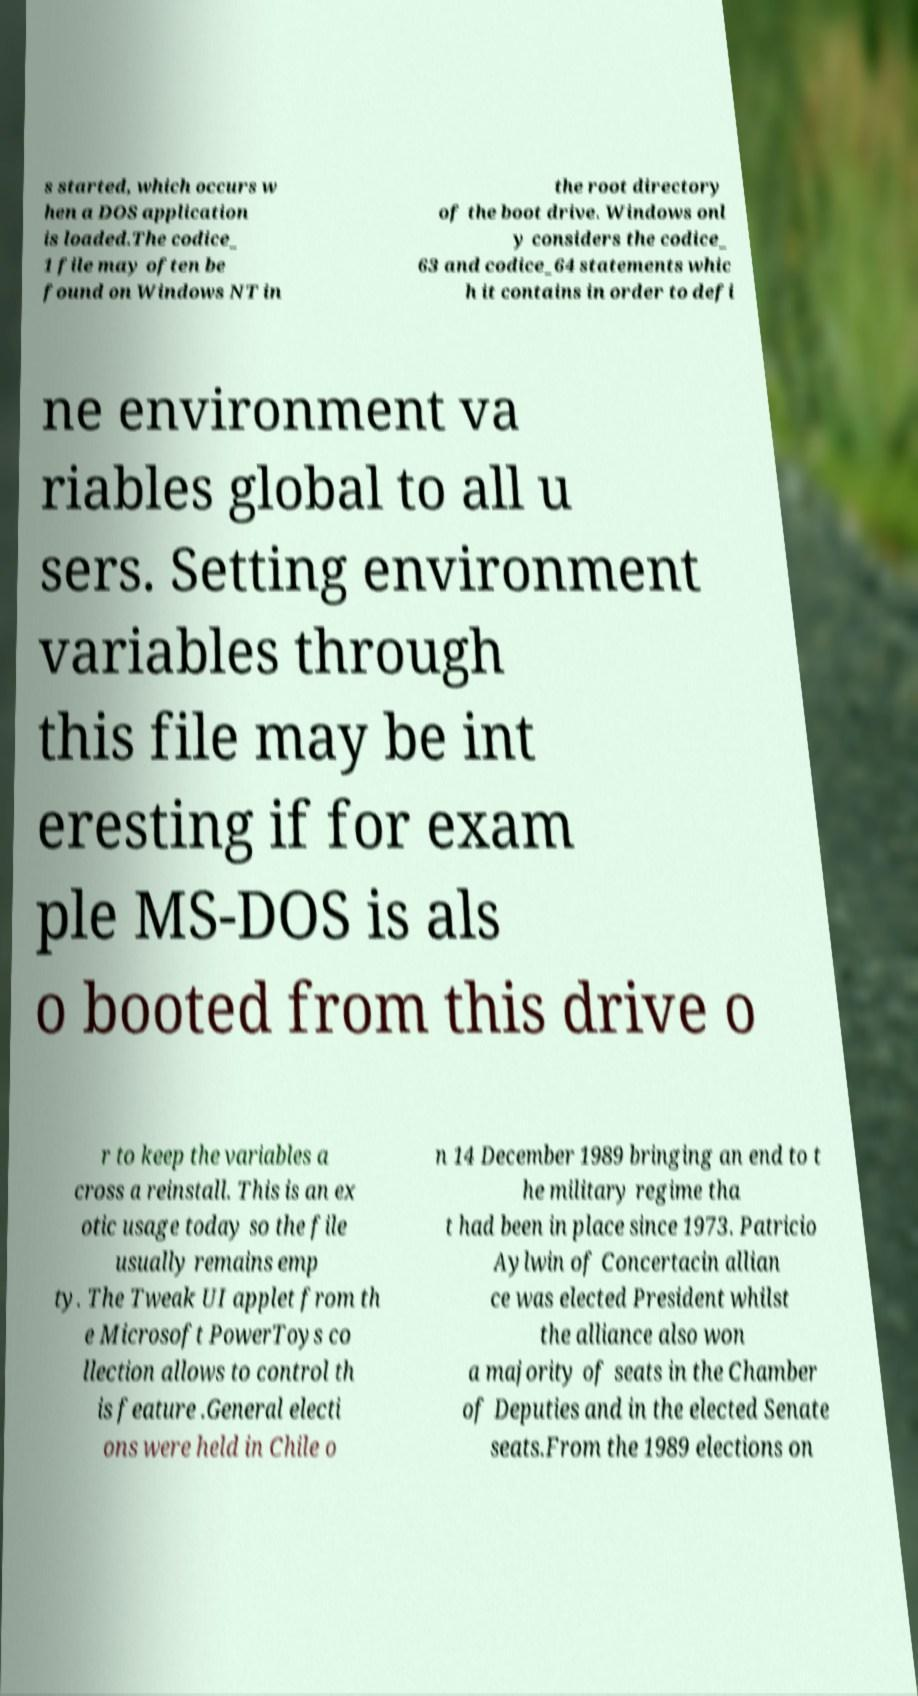Please identify and transcribe the text found in this image. s started, which occurs w hen a DOS application is loaded.The codice_ 1 file may often be found on Windows NT in the root directory of the boot drive. Windows onl y considers the codice_ 63 and codice_64 statements whic h it contains in order to defi ne environment va riables global to all u sers. Setting environment variables through this file may be int eresting if for exam ple MS-DOS is als o booted from this drive o r to keep the variables a cross a reinstall. This is an ex otic usage today so the file usually remains emp ty. The Tweak UI applet from th e Microsoft PowerToys co llection allows to control th is feature .General electi ons were held in Chile o n 14 December 1989 bringing an end to t he military regime tha t had been in place since 1973. Patricio Aylwin of Concertacin allian ce was elected President whilst the alliance also won a majority of seats in the Chamber of Deputies and in the elected Senate seats.From the 1989 elections on 